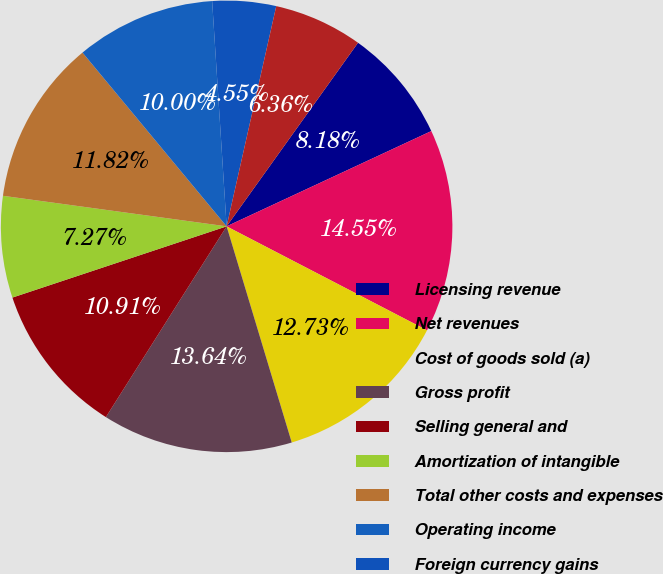Convert chart to OTSL. <chart><loc_0><loc_0><loc_500><loc_500><pie_chart><fcel>Licensing revenue<fcel>Net revenues<fcel>Cost of goods sold (a)<fcel>Gross profit<fcel>Selling general and<fcel>Amortization of intangible<fcel>Total other costs and expenses<fcel>Operating income<fcel>Foreign currency gains<fcel>Interest expense<nl><fcel>8.18%<fcel>14.55%<fcel>12.73%<fcel>13.64%<fcel>10.91%<fcel>7.27%<fcel>11.82%<fcel>10.0%<fcel>4.55%<fcel>6.36%<nl></chart> 